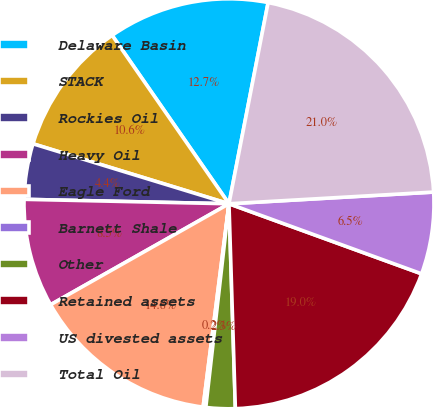Convert chart. <chart><loc_0><loc_0><loc_500><loc_500><pie_chart><fcel>Delaware Basin<fcel>STACK<fcel>Rockies Oil<fcel>Heavy Oil<fcel>Eagle Ford<fcel>Barnett Shale<fcel>Other<fcel>Retained assets<fcel>US divested assets<fcel>Total Oil<nl><fcel>12.71%<fcel>10.62%<fcel>4.38%<fcel>8.54%<fcel>14.79%<fcel>0.21%<fcel>2.3%<fcel>18.95%<fcel>6.46%<fcel>21.03%<nl></chart> 